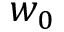Convert formula to latex. <formula><loc_0><loc_0><loc_500><loc_500>w _ { 0 }</formula> 